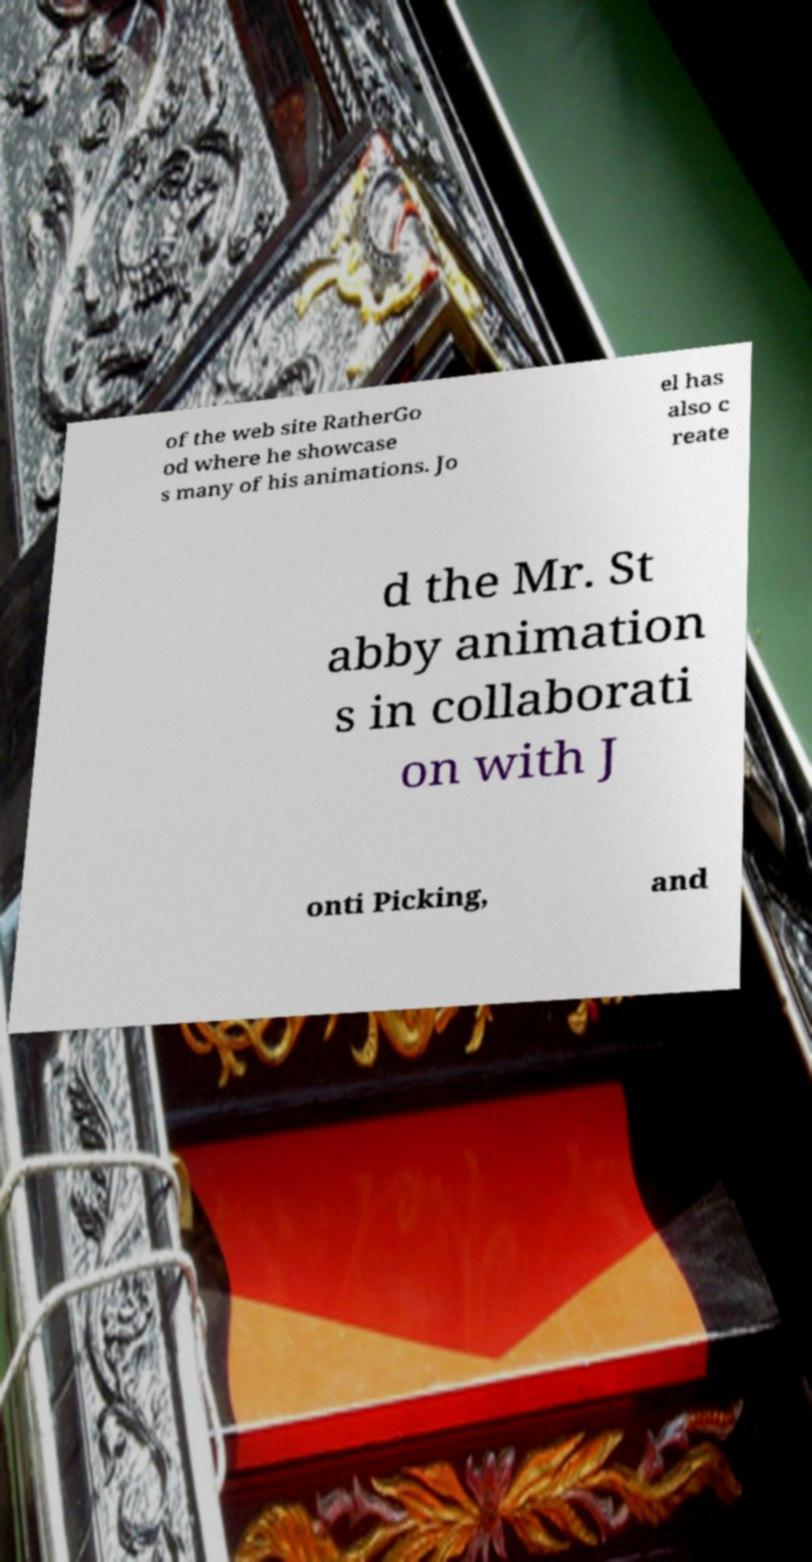For documentation purposes, I need the text within this image transcribed. Could you provide that? of the web site RatherGo od where he showcase s many of his animations. Jo el has also c reate d the Mr. St abby animation s in collaborati on with J onti Picking, and 